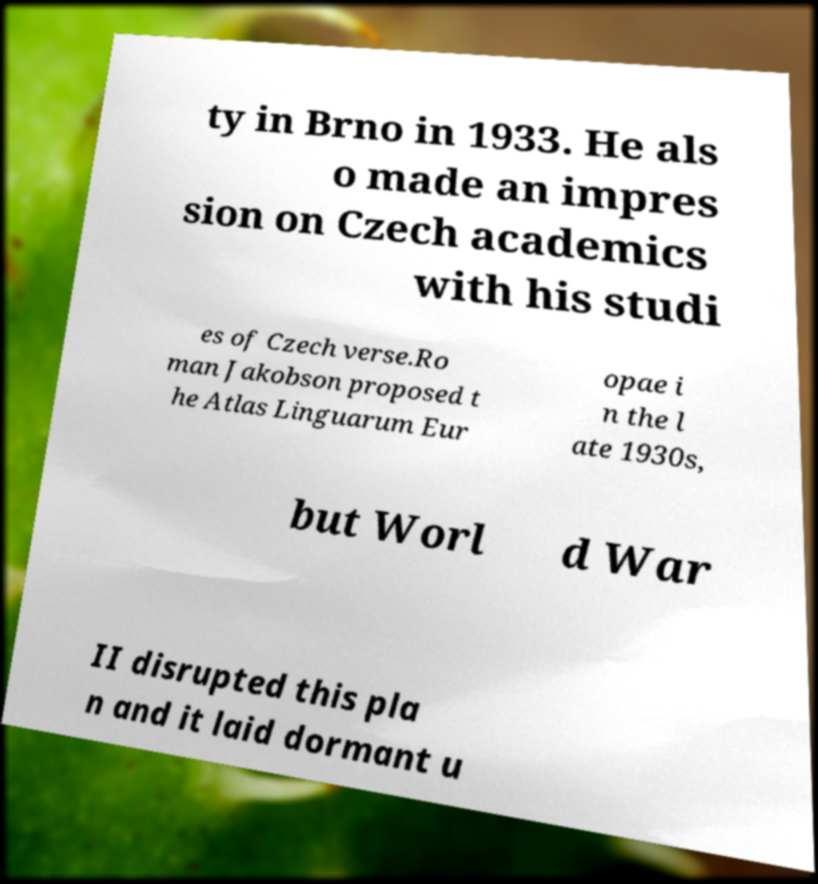Please identify and transcribe the text found in this image. ty in Brno in 1933. He als o made an impres sion on Czech academics with his studi es of Czech verse.Ro man Jakobson proposed t he Atlas Linguarum Eur opae i n the l ate 1930s, but Worl d War II disrupted this pla n and it laid dormant u 